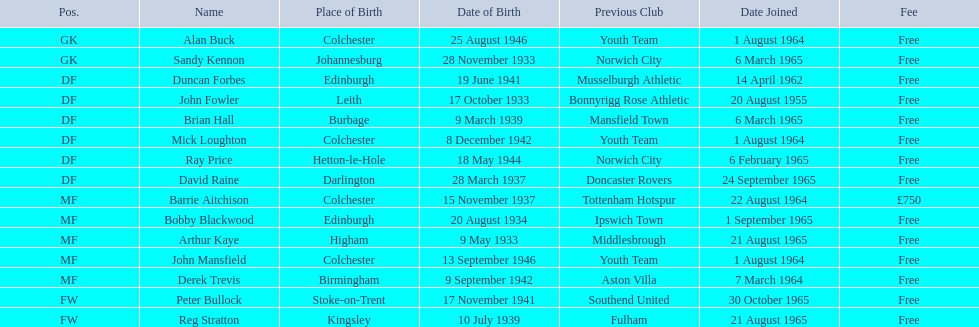Who are all the members involved? Alan Buck, Sandy Kennon, Duncan Forbes, John Fowler, Brian Hall, Mick Loughton, Ray Price, David Raine, Barrie Aitchison, Bobby Blackwood, Arthur Kaye, John Mansfield, Derek Trevis, Peter Bullock, Reg Stratton. When did each player become a part of the team? 1 August 1964, 6 March 1965, 14 April 1962, 20 August 1955, 6 March 1965, 1 August 1964, 6 February 1965, 24 September 1965, 22 August 1964, 1 September 1965, 21 August 1965, 1 August 1964, 7 March 1964, 30 October 1965, 21 August 1965. Who was the earliest member to join? John Fowler. When did the initial participant sign up? 20 August 1955. Can you give me this table as a dict? {'header': ['Pos.', 'Name', 'Place of Birth', 'Date of Birth', 'Previous Club', 'Date Joined', 'Fee'], 'rows': [['GK', 'Alan Buck', 'Colchester', '25 August 1946', 'Youth Team', '1 August 1964', 'Free'], ['GK', 'Sandy Kennon', 'Johannesburg', '28 November 1933', 'Norwich City', '6 March 1965', 'Free'], ['DF', 'Duncan Forbes', 'Edinburgh', '19 June 1941', 'Musselburgh Athletic', '14 April 1962', 'Free'], ['DF', 'John Fowler', 'Leith', '17 October 1933', 'Bonnyrigg Rose Athletic', '20 August 1955', 'Free'], ['DF', 'Brian Hall', 'Burbage', '9 March 1939', 'Mansfield Town', '6 March 1965', 'Free'], ['DF', 'Mick Loughton', 'Colchester', '8 December 1942', 'Youth Team', '1 August 1964', 'Free'], ['DF', 'Ray Price', 'Hetton-le-Hole', '18 May 1944', 'Norwich City', '6 February 1965', 'Free'], ['DF', 'David Raine', 'Darlington', '28 March 1937', 'Doncaster Rovers', '24 September 1965', 'Free'], ['MF', 'Barrie Aitchison', 'Colchester', '15 November 1937', 'Tottenham Hotspur', '22 August 1964', '£750'], ['MF', 'Bobby Blackwood', 'Edinburgh', '20 August 1934', 'Ipswich Town', '1 September 1965', 'Free'], ['MF', 'Arthur Kaye', 'Higham', '9 May 1933', 'Middlesbrough', '21 August 1965', 'Free'], ['MF', 'John Mansfield', 'Colchester', '13 September 1946', 'Youth Team', '1 August 1964', 'Free'], ['MF', 'Derek Trevis', 'Birmingham', '9 September 1942', 'Aston Villa', '7 March 1964', 'Free'], ['FW', 'Peter Bullock', 'Stoke-on-Trent', '17 November 1941', 'Southend United', '30 October 1965', 'Free'], ['FW', 'Reg Stratton', 'Kingsley', '10 July 1939', 'Fulham', '21 August 1965', 'Free']]} 